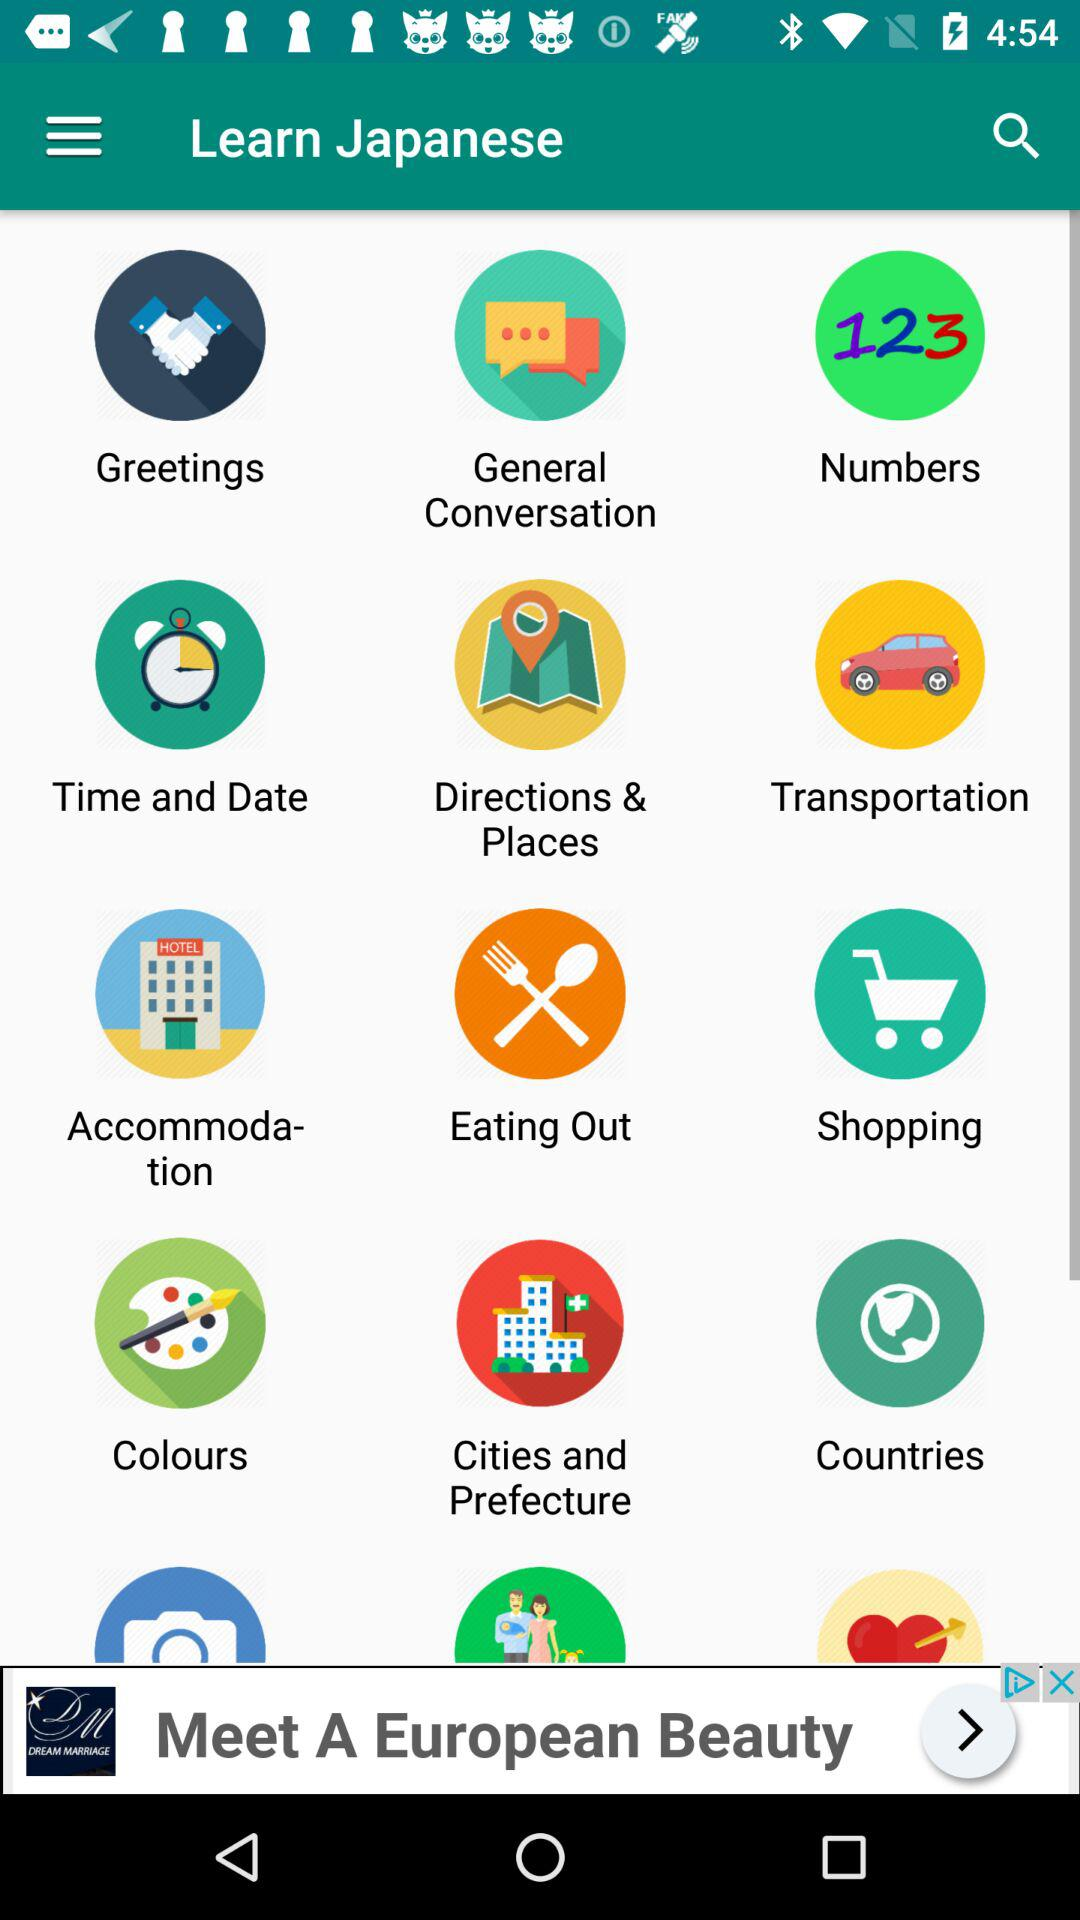What is the application name? The application name is "Learn Japanese". 